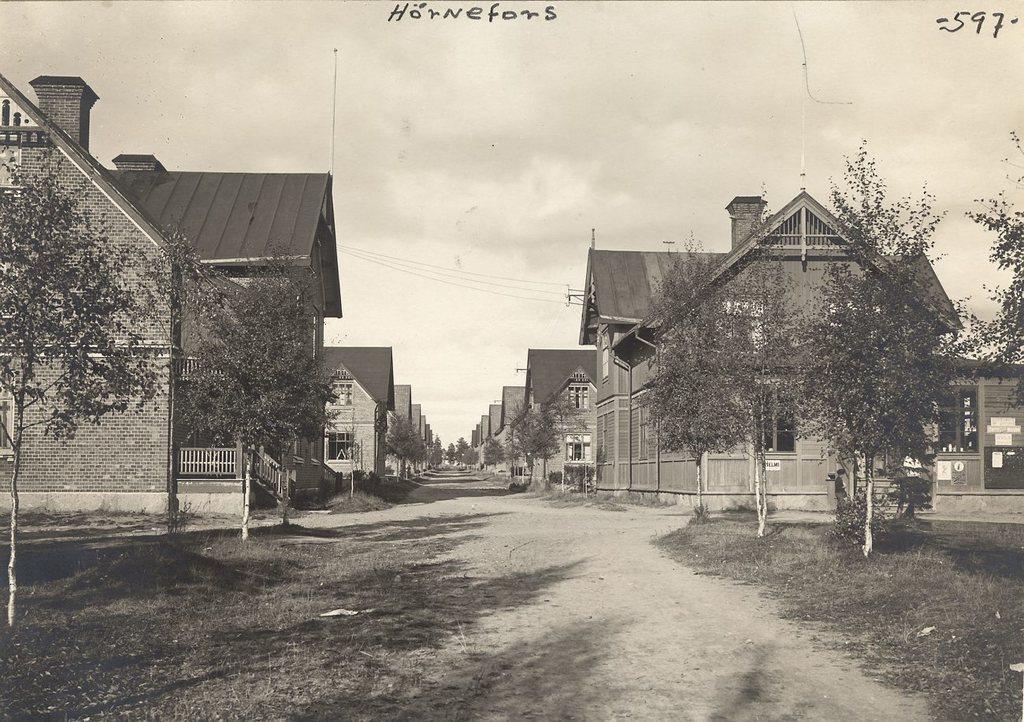Please provide a concise description of this image. In this image I can see grass, trees, buildings, fence, poles, text and the sky. This image is taken may be on the road. 